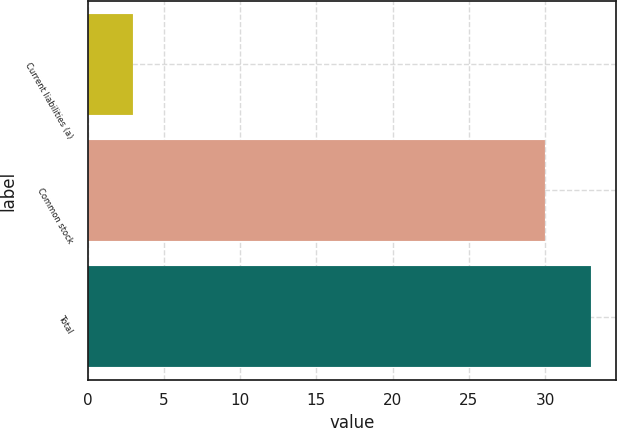Convert chart. <chart><loc_0><loc_0><loc_500><loc_500><bar_chart><fcel>Current liabilities (a)<fcel>Common stock<fcel>Total<nl><fcel>3<fcel>30<fcel>33<nl></chart> 